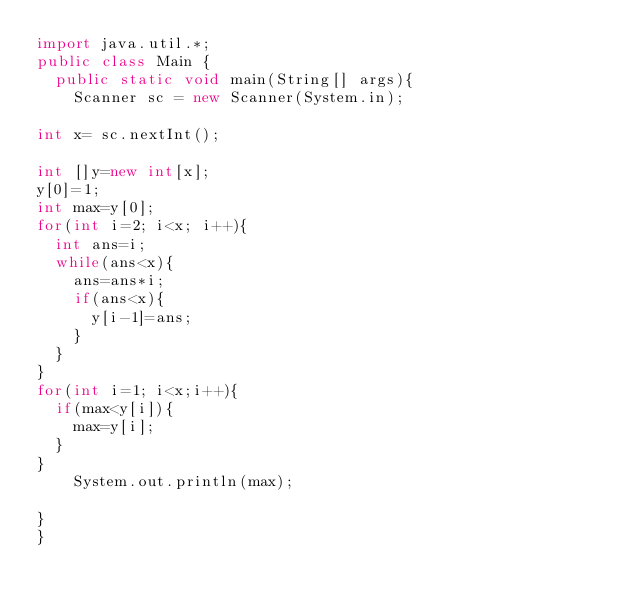Convert code to text. <code><loc_0><loc_0><loc_500><loc_500><_Java_>import java.util.*;
public class Main {
	public static void main(String[] args){
		Scanner sc = new Scanner(System.in);

int x= sc.nextInt();

int []y=new int[x];
y[0]=1;
int max=y[0];
for(int i=2; i<x; i++){
	int ans=i;
	while(ans<x){
		ans=ans*i;
		if(ans<x){
			y[i-1]=ans;
		}
	}
}
for(int i=1; i<x;i++){
	if(max<y[i]){
		max=y[i];
	}
}
		System.out.println(max);

}
}
</code> 